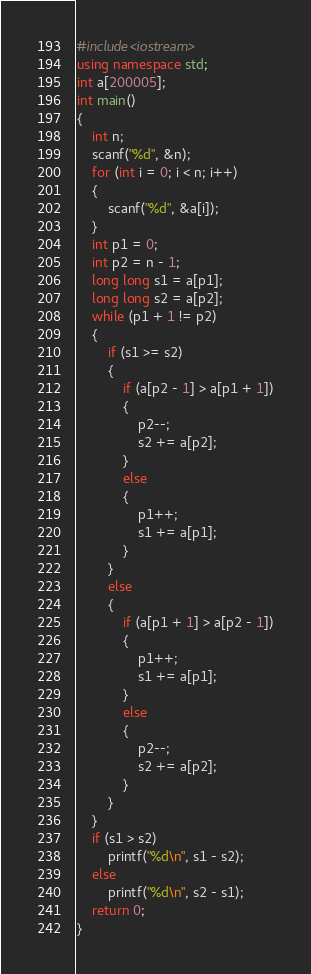Convert code to text. <code><loc_0><loc_0><loc_500><loc_500><_C++_>#include<iostream>
using namespace std;
int a[200005];
int main()
{
	int n;
	scanf("%d", &n);
	for (int i = 0; i < n; i++)
	{
		scanf("%d", &a[i]);
	}
	int p1 = 0;
	int p2 = n - 1;
	long long s1 = a[p1];
	long long s2 = a[p2];
	while (p1 + 1 != p2)
	{
		if (s1 >= s2)
		{
			if (a[p2 - 1] > a[p1 + 1])
			{
				p2--;
				s2 += a[p2];
			}
			else
			{
				p1++;
				s1 += a[p1];
			}
		}
		else
		{
			if (a[p1 + 1] > a[p2 - 1])
			{
				p1++;
				s1 += a[p1];
			}
			else
			{
				p2--;
				s2 += a[p2];
			}
		}
	}
	if (s1 > s2)
		printf("%d\n", s1 - s2);
	else
		printf("%d\n", s2 - s1);
	return 0;
}
</code> 